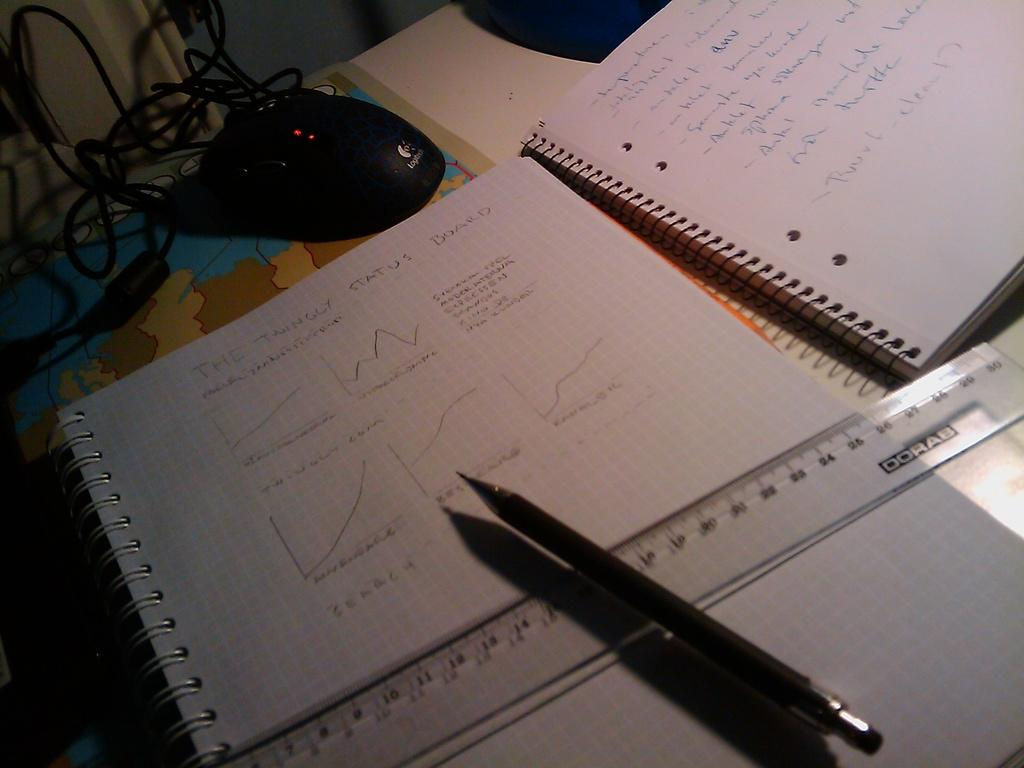<image>
Create a compact narrative representing the image presented. Two notebooks with writing about The Twingly Status Board on a desk with a pen and ruler 